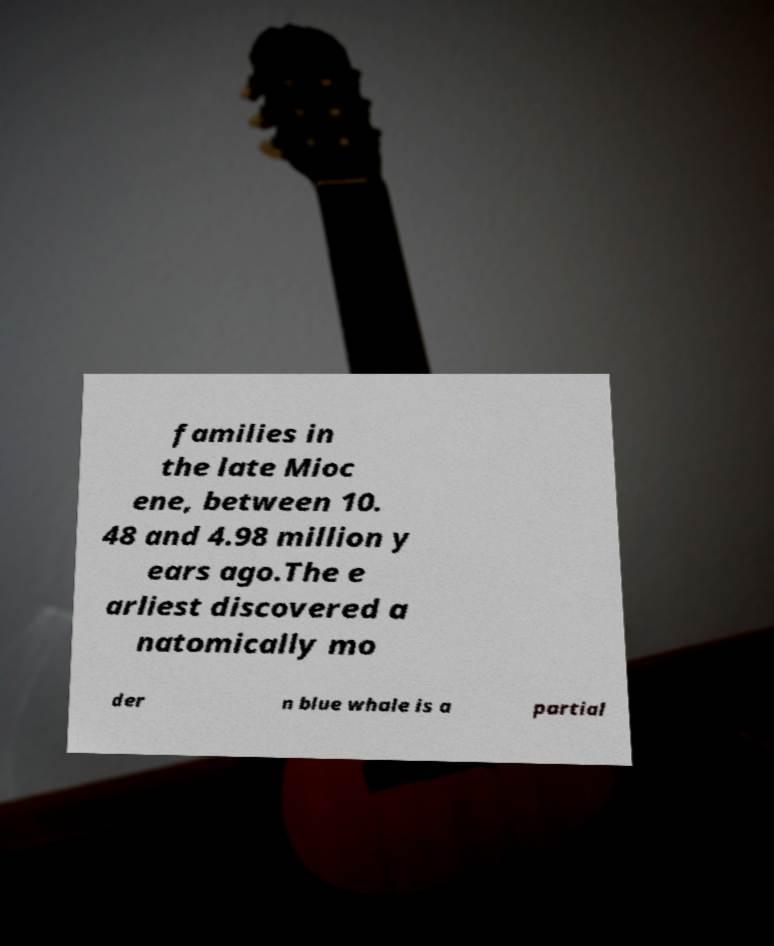What messages or text are displayed in this image? I need them in a readable, typed format. families in the late Mioc ene, between 10. 48 and 4.98 million y ears ago.The e arliest discovered a natomically mo der n blue whale is a partial 